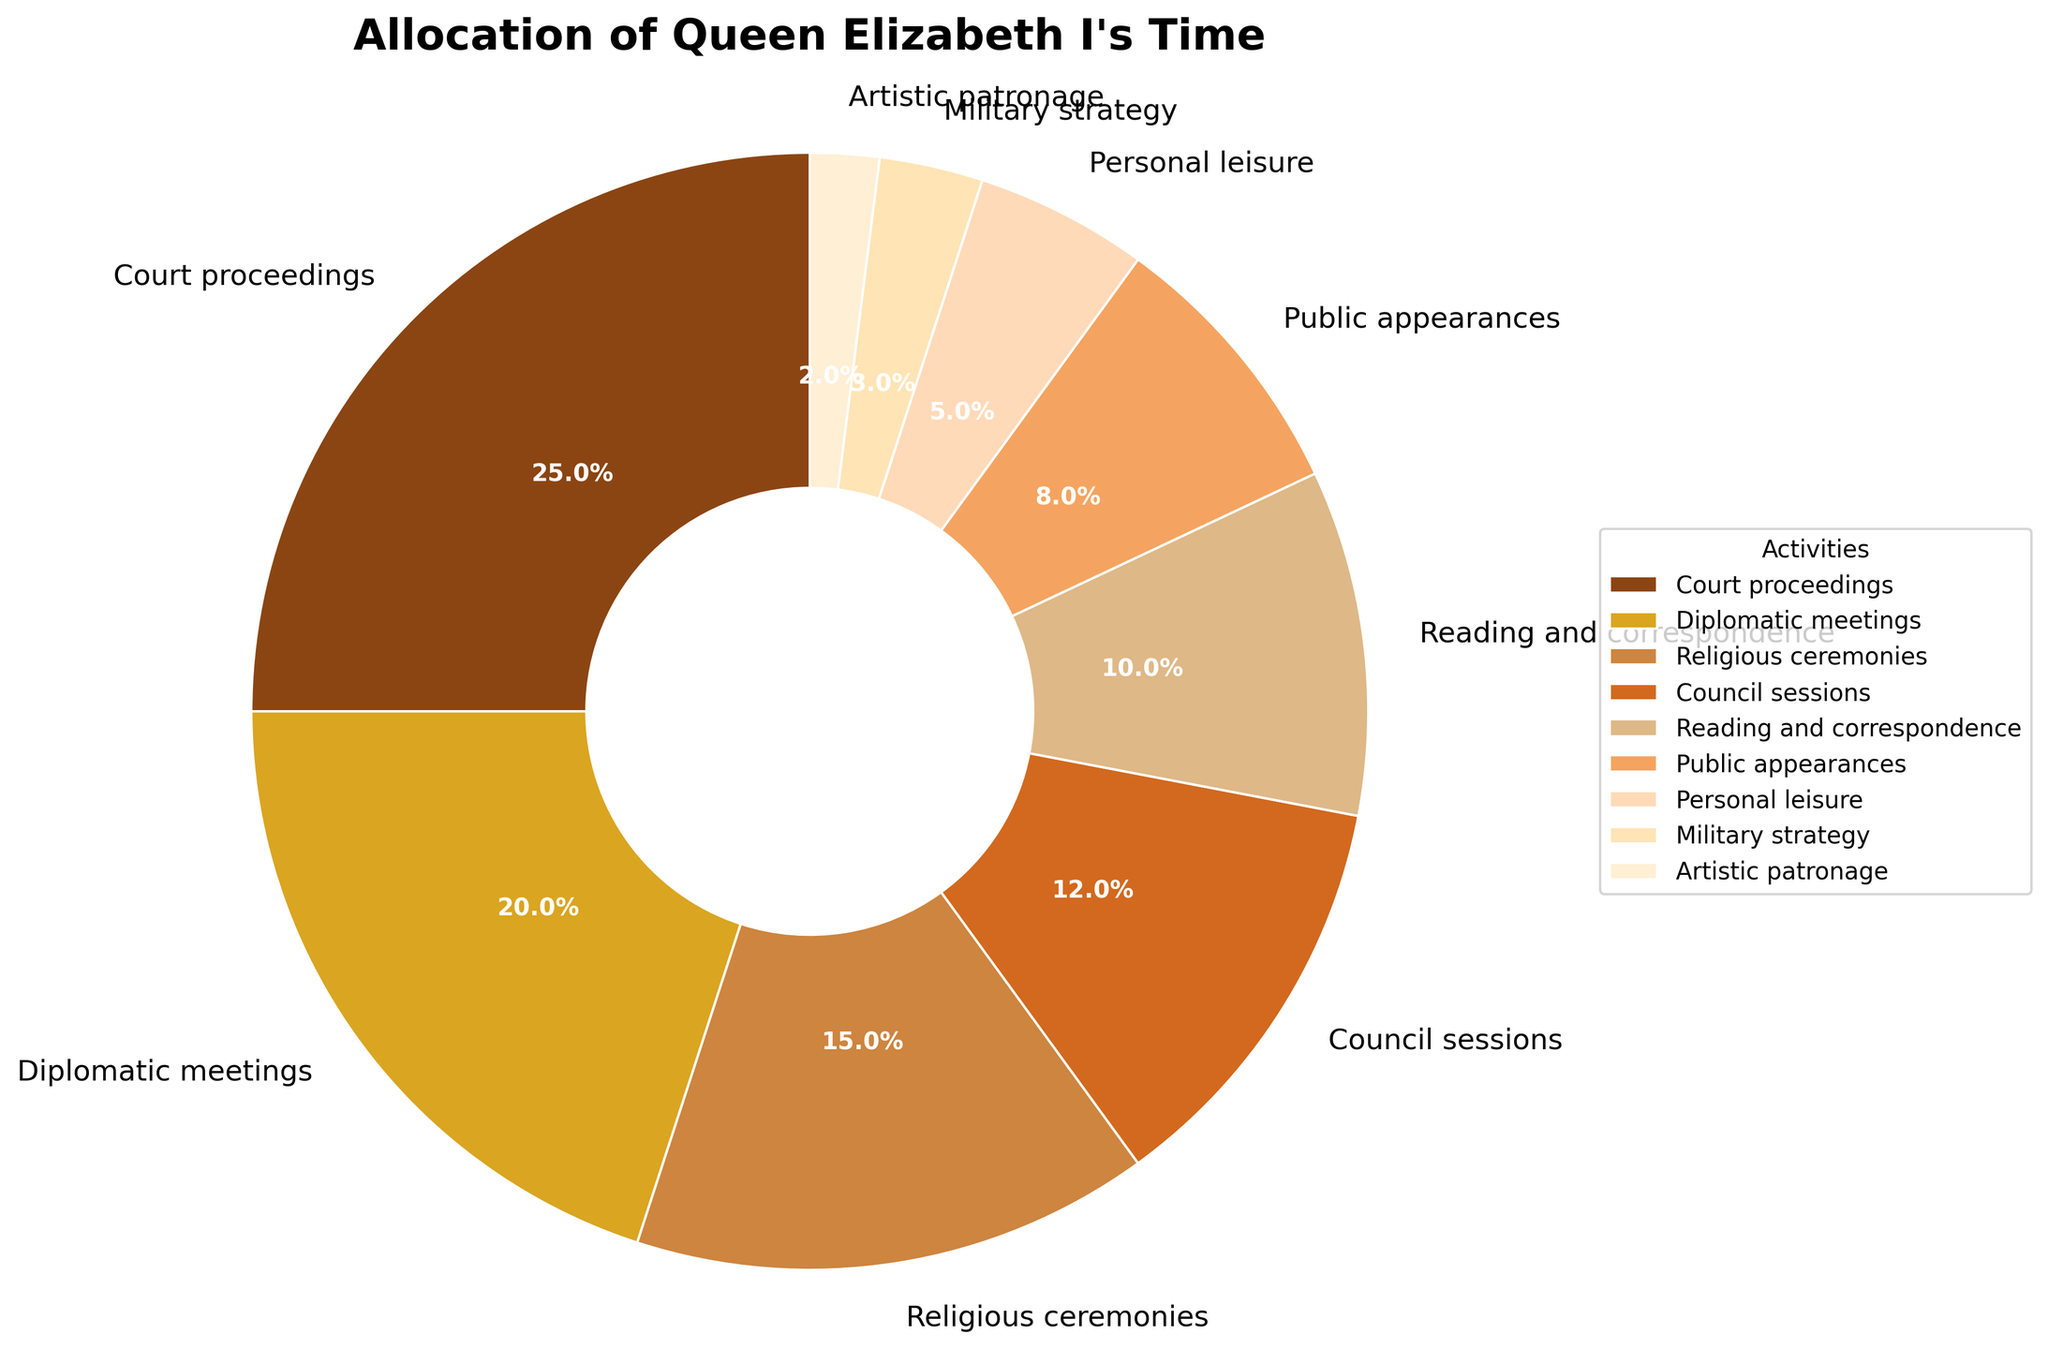What is the total percentage of time Queen Elizabeth I spends on court proceedings and council sessions? Sum the percentages of court proceedings (25%) and council sessions (12%). Therefore, the total is 25% + 12% = 37%.
Answer: 37% Which activity occupies more of the Queen's time, reading and correspondence or public appearances, and by how much? Compare the two percentages: reading and correspondence is 10%, and public appearances is 8%. The difference is 10% - 8% = 2%.
Answer: Reading and correspondence by 2% What percentage of Queen Elizabeth I's time is allocated to activities involving the court, including court proceedings, council sessions, and diplomatic meetings? Add the percentages of court proceedings (25%), council sessions (12%), and diplomatic meetings (20%). 25% + 12% + 20% = 57%.
Answer: 57% Which activity is depicted using the lightest shade of brown in the pie chart? Identify the section with the lightest color and the corresponding label in the pie chart, which is artistic patronage (2%).
Answer: Artistic patronage If we combine the time spent on religious ceremonies, military strategy, and artistic patronage, is it more or less than the time spent on diplomatic meetings? Add the percentages of religious ceremonies (15%), military strategy (3%), and artistic patronage (2%), which totals 15% + 3% + 2% = 20%. Compare it to diplomatic meetings (20%).
Answer: Equal to Which two activities combined take up approximately 30% of Queen Elizabeth I's time? Identify two activities whose combined percentages equal around 30%. Public appearances (8%) and reading and correspondence (10%) together add up to 18%, while court proceedings (25%) and military strategy (3%) add up to 28%, which is closer to 30%. Therefore, it's court proceedings and military strategy.
Answer: Court proceedings and military strategy Is there more time spent on personal leisure or military strategy, and what is the difference? Compare the percentages of personal leisure (5%) and military strategy (3%). The difference is 5% - 3% = 2%.
Answer: Personal leisure by 2% How much more time does Queen Elizabeth I spend on court proceedings compared to public appearances? Subtract the percentage of public appearances (8%) from court proceedings (25%). The difference is 25% - 8% = 17%.
Answer: 17% What is the combined percentage of time allocated to activities related to warfare, including military strategy and public appearances? Sum the percentages of military strategy (3%) and public appearances (8%), giving 3% + 8% = 11%.
Answer: 11% 